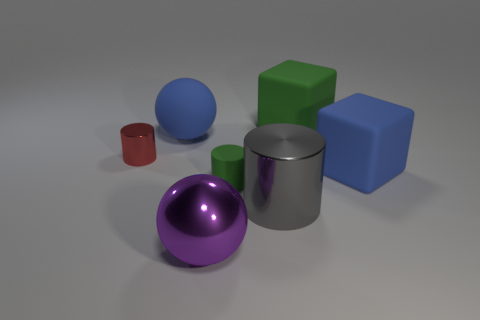How many objects are there in total? There are a total of six objects visible in the image. Can you describe their colors and shapes? Certainly! From left to right, there's a medium-sized, matte gray cylinder, a large, shiny purple sphere, a small, shiny red cylinder, a medium-sized, matte blue sphere, a medium-to-large matte green cube, and a large, shiny blue cube. 